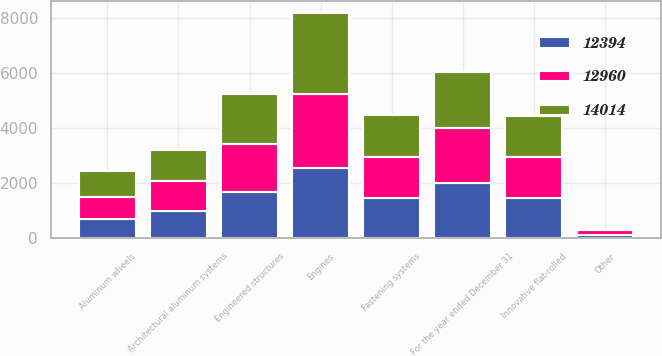<chart> <loc_0><loc_0><loc_500><loc_500><stacked_bar_chart><ecel><fcel>For the year ended December 31<fcel>Innovative flat-rolled<fcel>Engines<fcel>Engineered structures<fcel>Fastening systems<fcel>Architectural aluminum systems<fcel>Aluminum wheels<fcel>Other<nl><fcel>14014<fcel>2018<fcel>1484<fcel>2940<fcel>1839<fcel>1531<fcel>1140<fcel>969<fcel>7<nl><fcel>12960<fcel>2017<fcel>1484<fcel>2708<fcel>1743<fcel>1484<fcel>1065<fcel>805<fcel>163<nl><fcel>12394<fcel>2016<fcel>1484<fcel>2560<fcel>1683<fcel>1463<fcel>1010<fcel>689<fcel>125<nl></chart> 